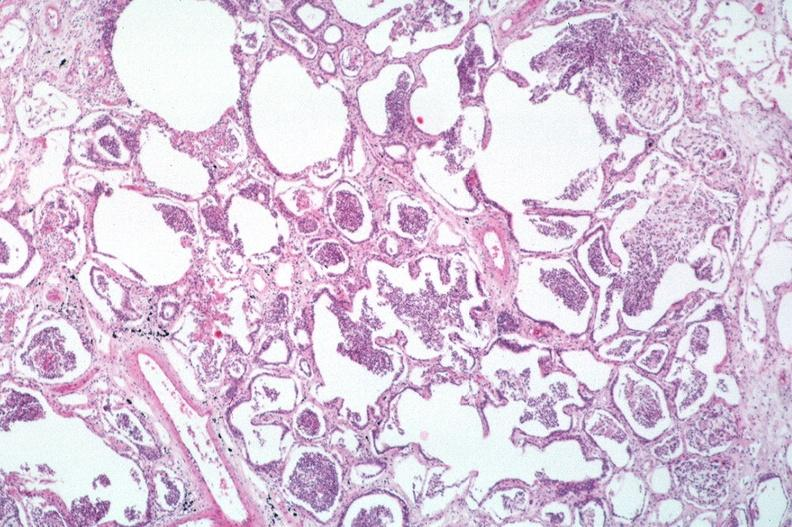does this image show lung, bronchopneumonia?
Answer the question using a single word or phrase. Yes 